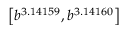Convert formula to latex. <formula><loc_0><loc_0><loc_500><loc_500>\left [ b ^ { 3 . 1 4 1 5 9 } , b ^ { 3 . 1 4 1 6 0 } \right ]</formula> 